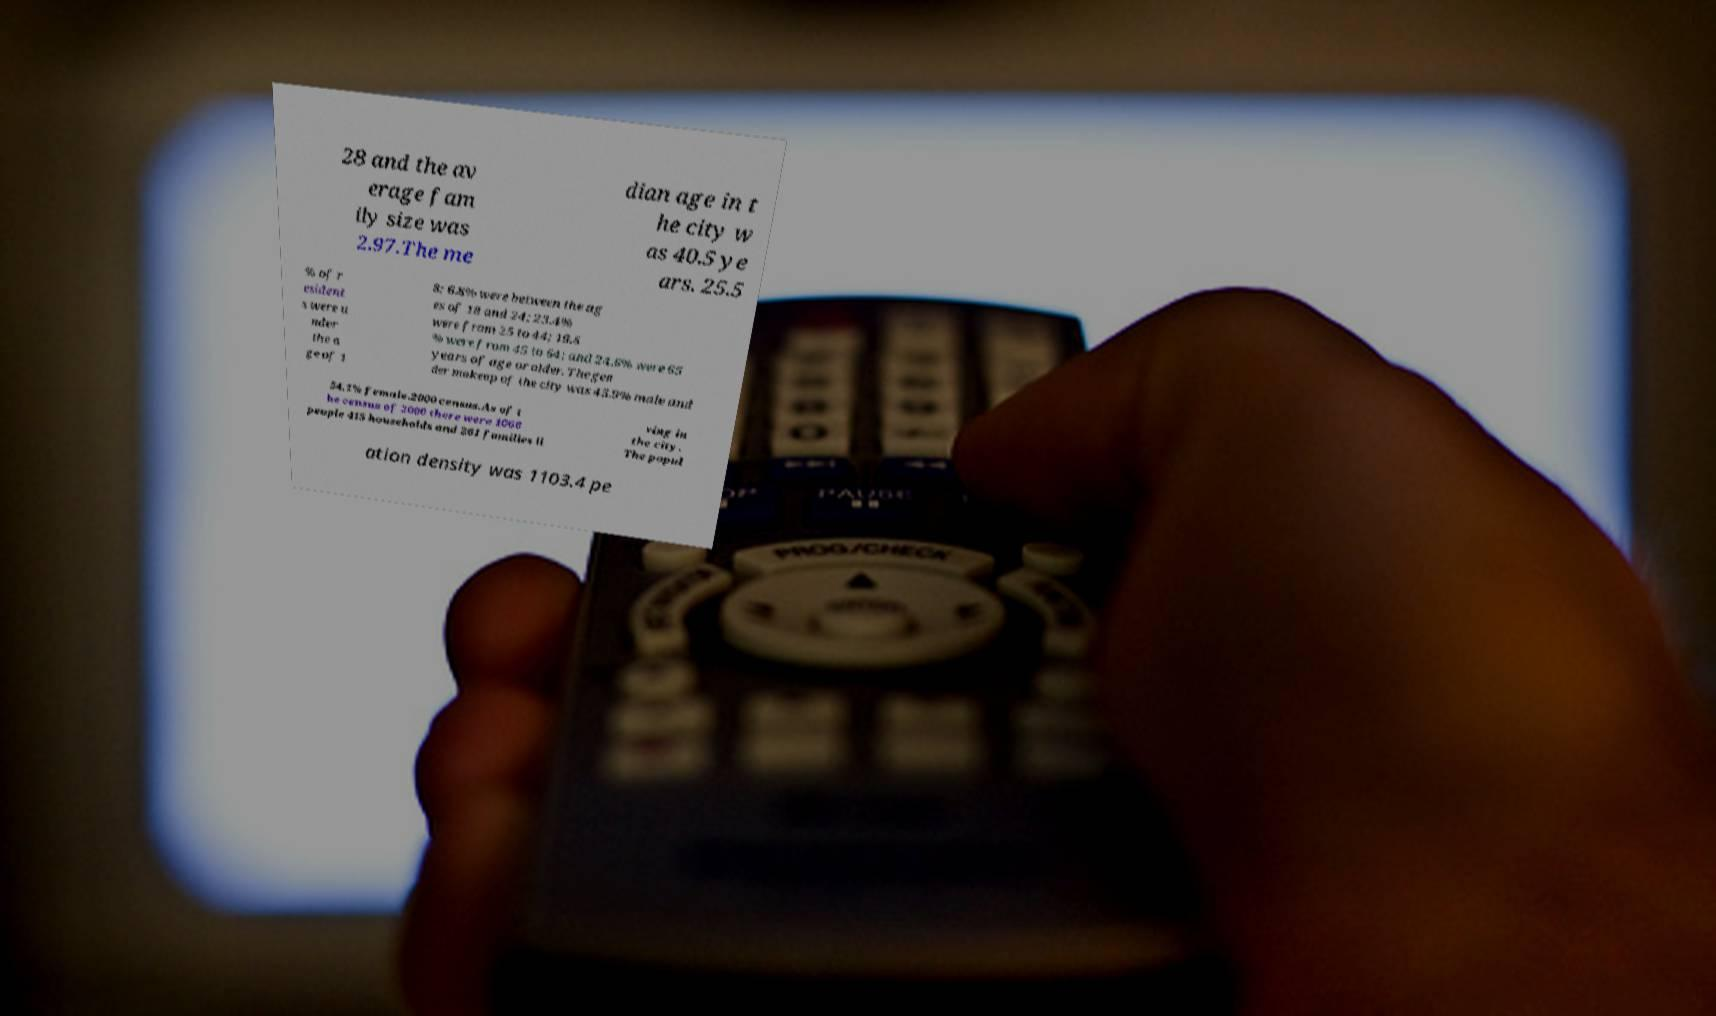I need the written content from this picture converted into text. Can you do that? 28 and the av erage fam ily size was 2.97.The me dian age in t he city w as 40.5 ye ars. 25.5 % of r esident s were u nder the a ge of 1 8; 6.8% were between the ag es of 18 and 24; 23.4% were from 25 to 44; 19.6 % were from 45 to 64; and 24.6% were 65 years of age or older. The gen der makeup of the city was 45.9% male and 54.1% female.2000 census.As of t he census of 2000 there were 1066 people 415 households and 261 families li ving in the city. The popul ation density was 1103.4 pe 